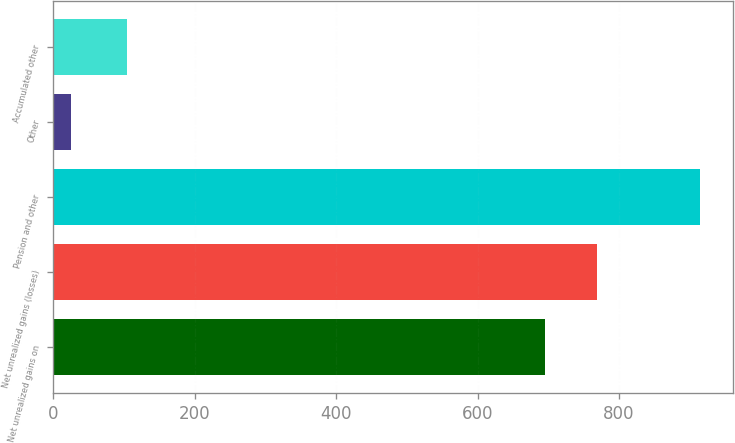Convert chart to OTSL. <chart><loc_0><loc_0><loc_500><loc_500><bar_chart><fcel>Net unrealized gains on<fcel>Net unrealized gains (losses)<fcel>Pension and other<fcel>Other<fcel>Accumulated other<nl><fcel>696<fcel>769<fcel>915<fcel>25<fcel>105<nl></chart> 